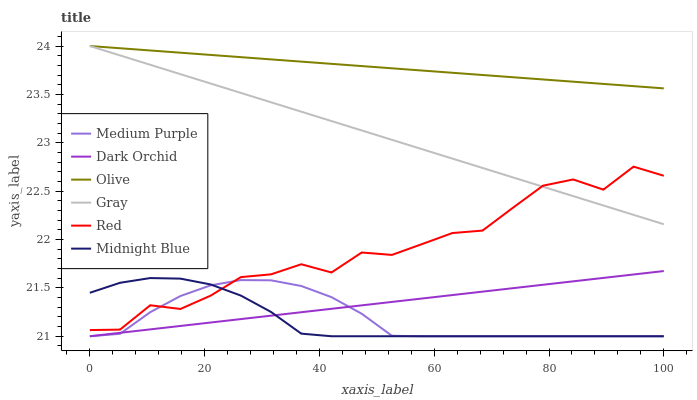Does Midnight Blue have the minimum area under the curve?
Answer yes or no. Yes. Does Olive have the maximum area under the curve?
Answer yes or no. Yes. Does Dark Orchid have the minimum area under the curve?
Answer yes or no. No. Does Dark Orchid have the maximum area under the curve?
Answer yes or no. No. Is Dark Orchid the smoothest?
Answer yes or no. Yes. Is Red the roughest?
Answer yes or no. Yes. Is Midnight Blue the smoothest?
Answer yes or no. No. Is Midnight Blue the roughest?
Answer yes or no. No. Does Midnight Blue have the lowest value?
Answer yes or no. Yes. Does Olive have the lowest value?
Answer yes or no. No. Does Olive have the highest value?
Answer yes or no. Yes. Does Midnight Blue have the highest value?
Answer yes or no. No. Is Midnight Blue less than Gray?
Answer yes or no. Yes. Is Gray greater than Dark Orchid?
Answer yes or no. Yes. Does Medium Purple intersect Dark Orchid?
Answer yes or no. Yes. Is Medium Purple less than Dark Orchid?
Answer yes or no. No. Is Medium Purple greater than Dark Orchid?
Answer yes or no. No. Does Midnight Blue intersect Gray?
Answer yes or no. No. 